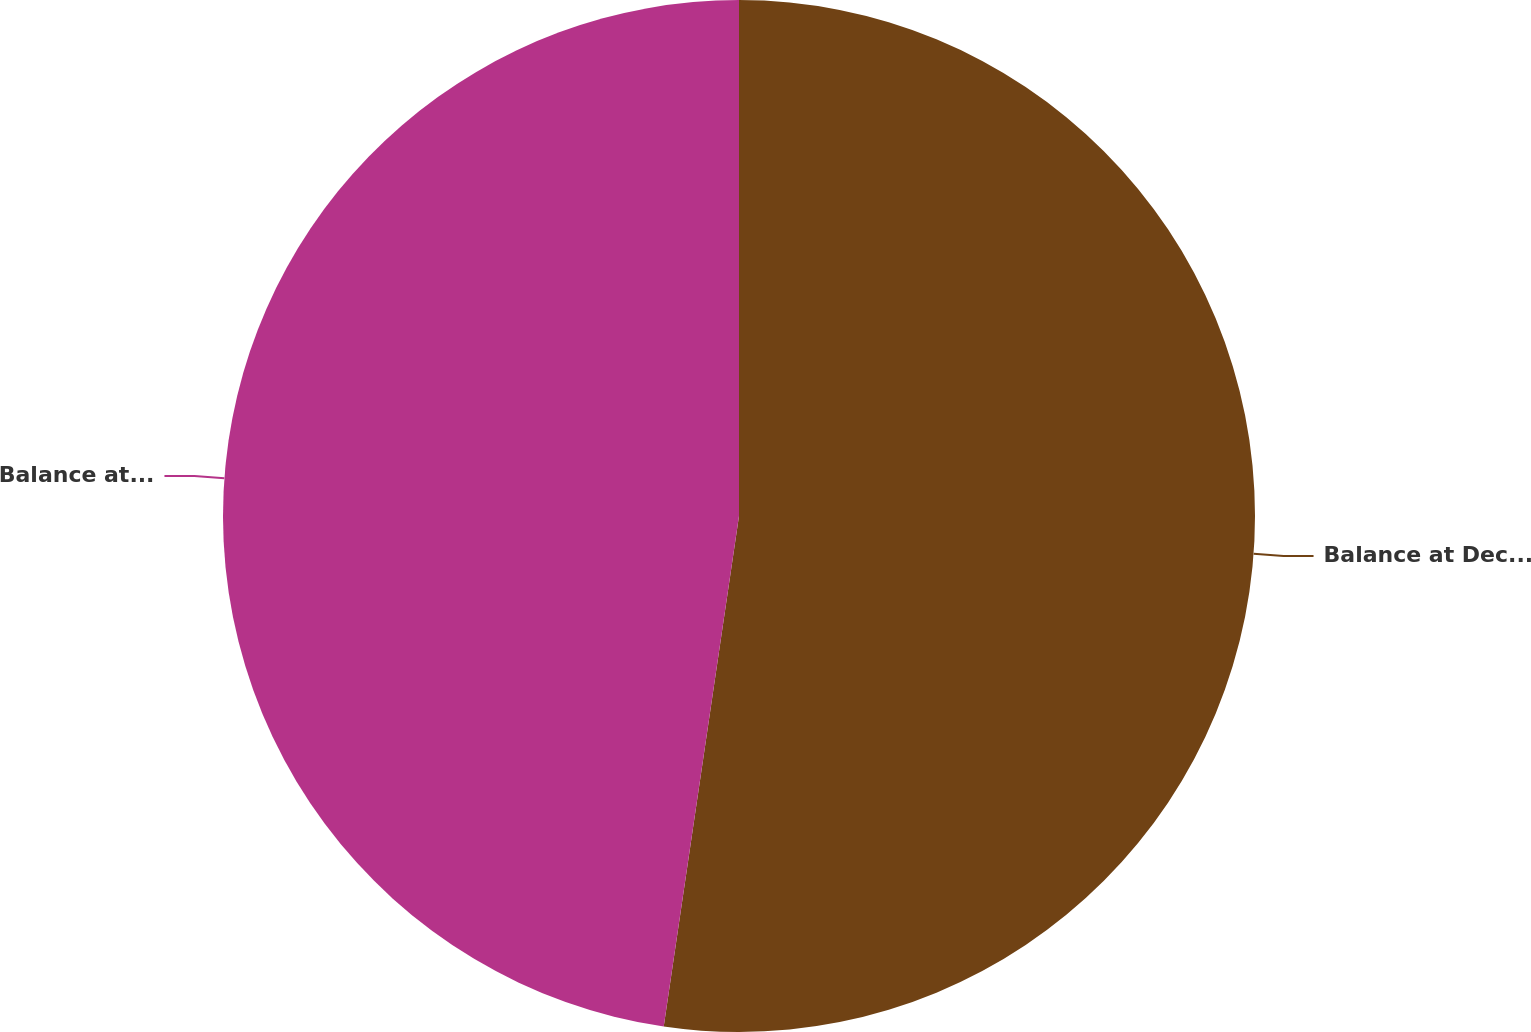<chart> <loc_0><loc_0><loc_500><loc_500><pie_chart><fcel>Balance at December 31 2006<fcel>Balance at December 31 2007<nl><fcel>52.33%<fcel>47.67%<nl></chart> 